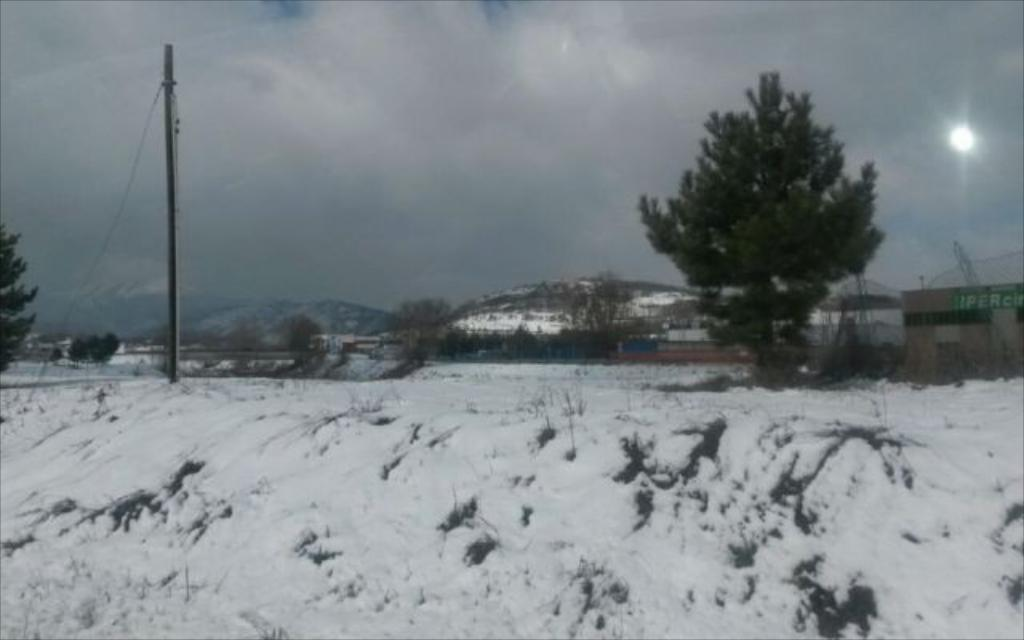What type of weather is depicted in the image? The image shows snow at the bottom, which indicates cold weather. What can be seen in the middle of the image? There are trees in the middle of the image. What is the condition of the sky in the image? The sky is cloudy at the top of the image. How many children are playing on the tramp in the image? There are no children or tramp present in the image. What type of mark can be seen on the trees in the image? There are no marks visible on the trees in the image. 